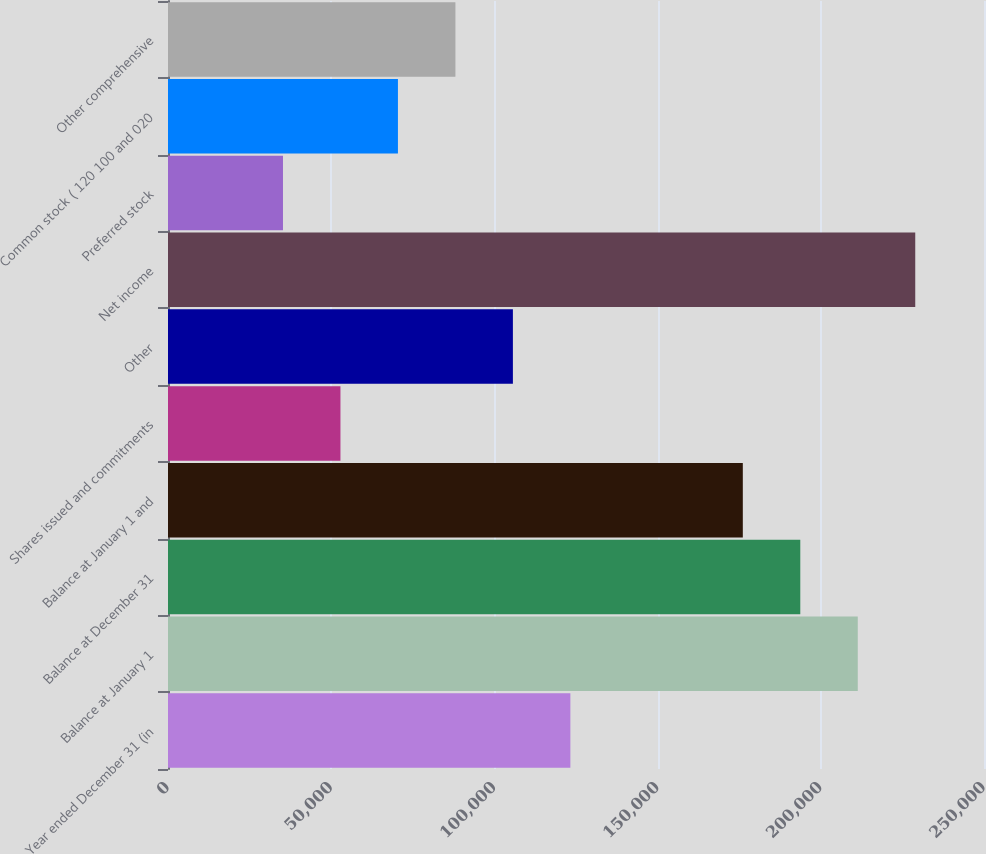Convert chart. <chart><loc_0><loc_0><loc_500><loc_500><bar_chart><fcel>Year ended December 31 (in<fcel>Balance at January 1<fcel>Balance at December 31<fcel>Balance at January 1 and<fcel>Shares issued and commitments<fcel>Other<fcel>Net income<fcel>Preferred stock<fcel>Common stock ( 120 100 and 020<fcel>Other comprehensive<nl><fcel>123276<fcel>211326<fcel>193716<fcel>176106<fcel>52835.3<fcel>105666<fcel>228936<fcel>35225.2<fcel>70445.4<fcel>88055.5<nl></chart> 